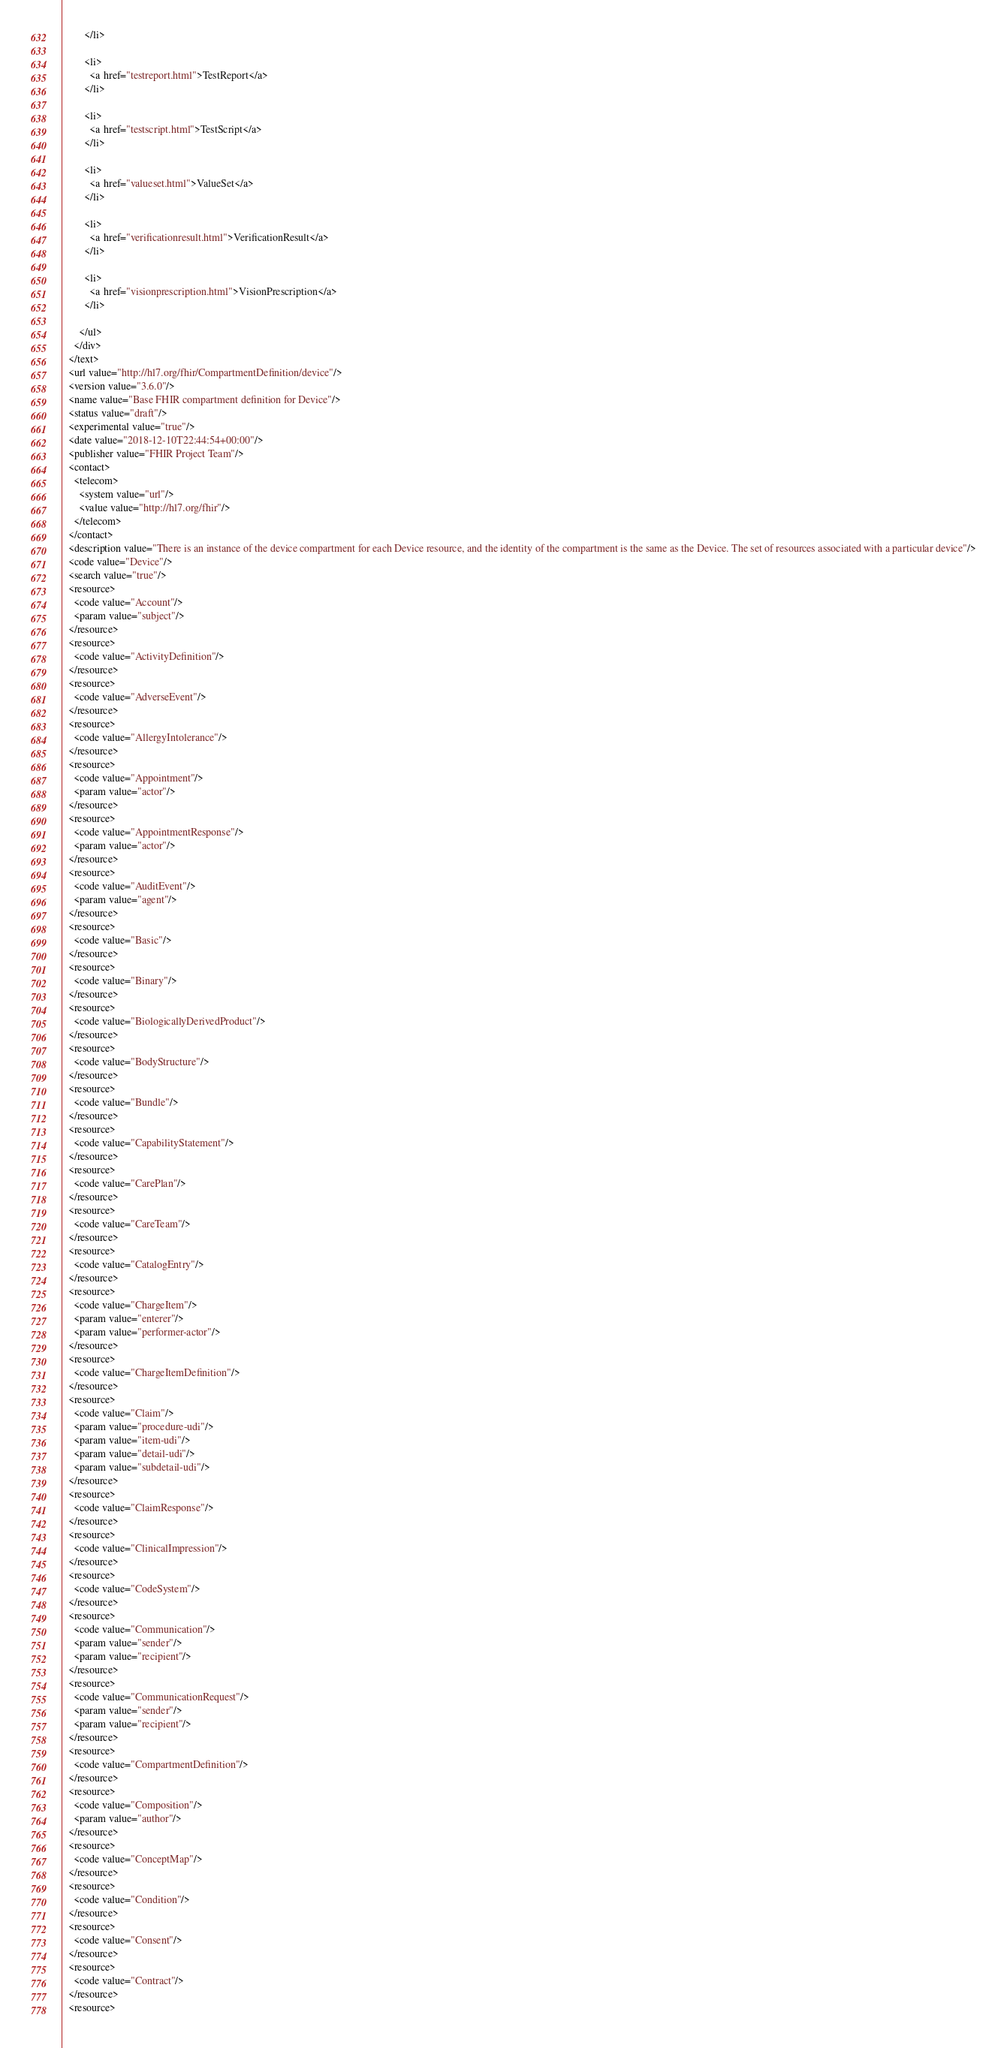Convert code to text. <code><loc_0><loc_0><loc_500><loc_500><_XML_>        </li>
 
        <li>
          <a href="testreport.html">TestReport</a>
        </li>
 
        <li>
          <a href="testscript.html">TestScript</a>
        </li>
 
        <li>
          <a href="valueset.html">ValueSet</a>
        </li>
 
        <li>
          <a href="verificationresult.html">VerificationResult</a>
        </li>
 
        <li>
          <a href="visionprescription.html">VisionPrescription</a>
        </li>

      </ul>
    </div>
  </text>
  <url value="http://hl7.org/fhir/CompartmentDefinition/device"/>
  <version value="3.6.0"/>
  <name value="Base FHIR compartment definition for Device"/>
  <status value="draft"/>
  <experimental value="true"/>
  <date value="2018-12-10T22:44:54+00:00"/>
  <publisher value="FHIR Project Team"/>
  <contact>
    <telecom>
      <system value="url"/>
      <value value="http://hl7.org/fhir"/>
    </telecom>
  </contact>
  <description value="There is an instance of the device compartment for each Device resource, and the identity of the compartment is the same as the Device. The set of resources associated with a particular device"/>
  <code value="Device"/>
  <search value="true"/>
  <resource>
    <code value="Account"/>
    <param value="subject"/>
  </resource>
  <resource>
    <code value="ActivityDefinition"/>
  </resource>
  <resource>
    <code value="AdverseEvent"/>
  </resource>
  <resource>
    <code value="AllergyIntolerance"/>
  </resource>
  <resource>
    <code value="Appointment"/>
    <param value="actor"/>
  </resource>
  <resource>
    <code value="AppointmentResponse"/>
    <param value="actor"/>
  </resource>
  <resource>
    <code value="AuditEvent"/>
    <param value="agent"/>
  </resource>
  <resource>
    <code value="Basic"/>
  </resource>
  <resource>
    <code value="Binary"/>
  </resource>
  <resource>
    <code value="BiologicallyDerivedProduct"/>
  </resource>
  <resource>
    <code value="BodyStructure"/>
  </resource>
  <resource>
    <code value="Bundle"/>
  </resource>
  <resource>
    <code value="CapabilityStatement"/>
  </resource>
  <resource>
    <code value="CarePlan"/>
  </resource>
  <resource>
    <code value="CareTeam"/>
  </resource>
  <resource>
    <code value="CatalogEntry"/>
  </resource>
  <resource>
    <code value="ChargeItem"/>
    <param value="enterer"/>
    <param value="performer-actor"/>
  </resource>
  <resource>
    <code value="ChargeItemDefinition"/>
  </resource>
  <resource>
    <code value="Claim"/>
    <param value="procedure-udi"/>
    <param value="item-udi"/>
    <param value="detail-udi"/>
    <param value="subdetail-udi"/>
  </resource>
  <resource>
    <code value="ClaimResponse"/>
  </resource>
  <resource>
    <code value="ClinicalImpression"/>
  </resource>
  <resource>
    <code value="CodeSystem"/>
  </resource>
  <resource>
    <code value="Communication"/>
    <param value="sender"/>
    <param value="recipient"/>
  </resource>
  <resource>
    <code value="CommunicationRequest"/>
    <param value="sender"/>
    <param value="recipient"/>
  </resource>
  <resource>
    <code value="CompartmentDefinition"/>
  </resource>
  <resource>
    <code value="Composition"/>
    <param value="author"/>
  </resource>
  <resource>
    <code value="ConceptMap"/>
  </resource>
  <resource>
    <code value="Condition"/>
  </resource>
  <resource>
    <code value="Consent"/>
  </resource>
  <resource>
    <code value="Contract"/>
  </resource>
  <resource></code> 